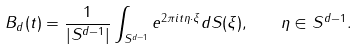Convert formula to latex. <formula><loc_0><loc_0><loc_500><loc_500>\ B _ { d } ( t ) = \frac { 1 } { | S ^ { d - 1 } | } \int _ { S ^ { d - 1 } } e ^ { 2 \pi i t \eta \cdot \xi } d S ( \xi ) , \quad \eta \in S ^ { d - 1 } .</formula> 